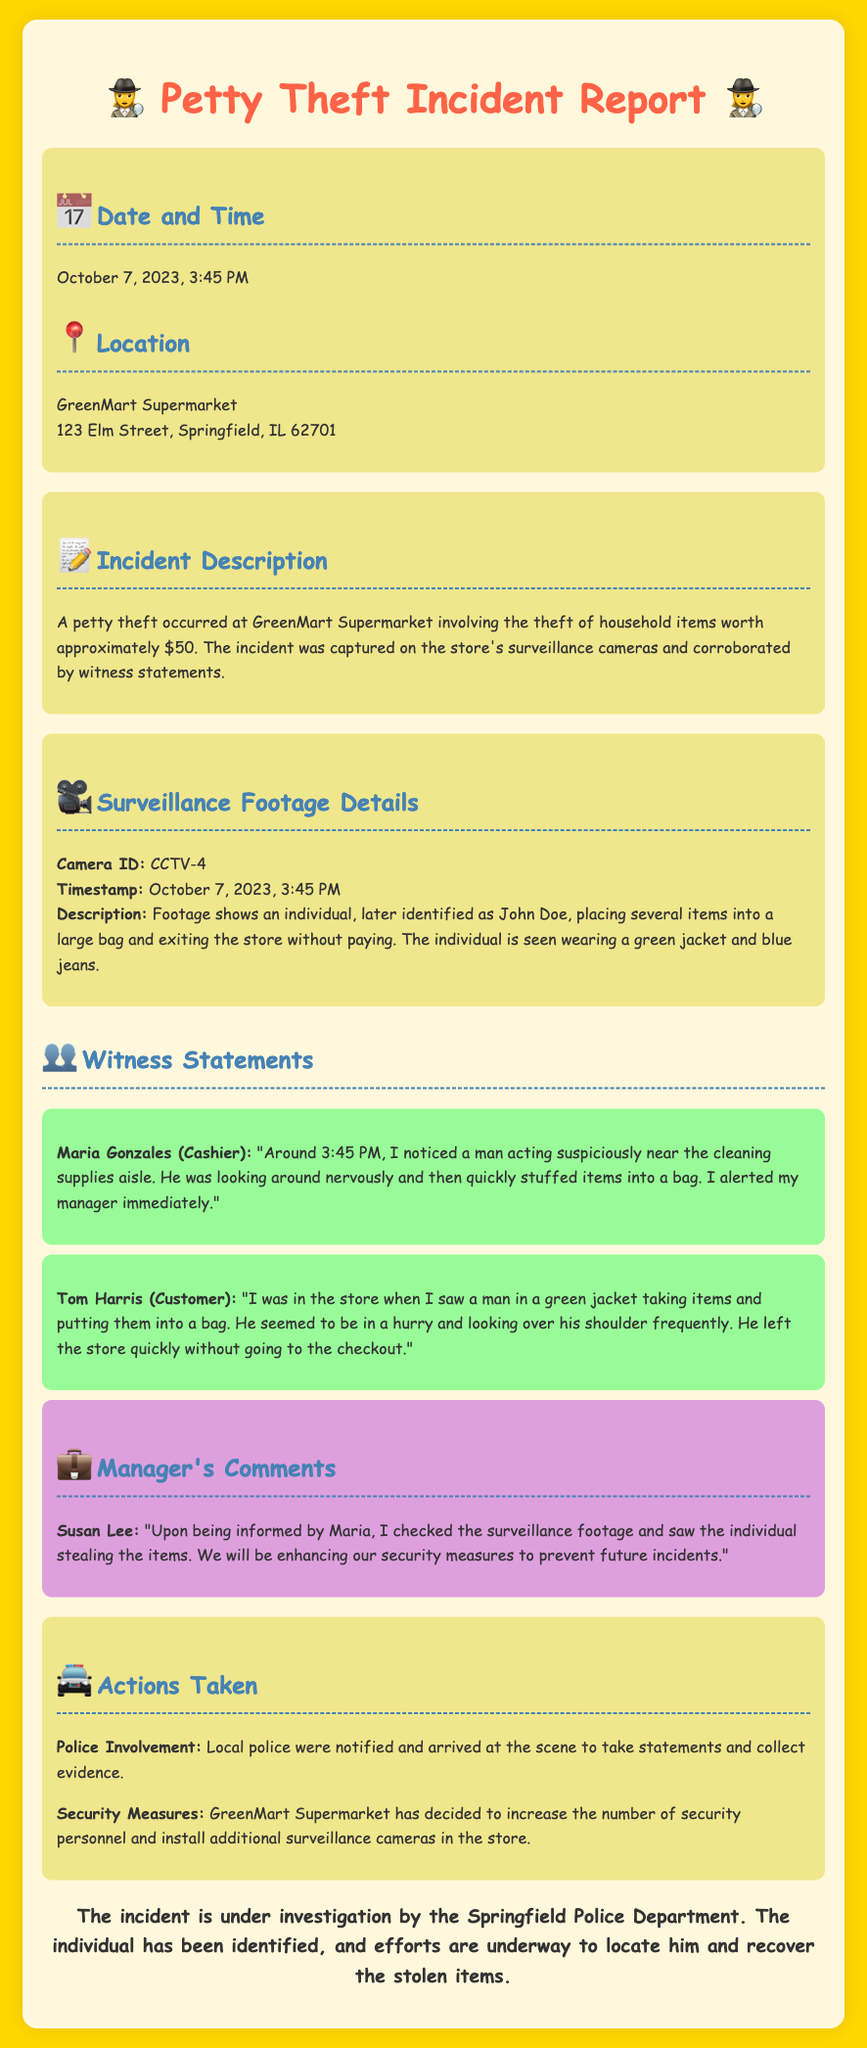What date did the incident occur? The date of the incident is stated in the report as October 7, 2023.
Answer: October 7, 2023 Who was the witness making the first statement? The first witness statement in the document is provided by Maria Gonzales, the cashier.
Answer: Maria Gonzales What items were stolen? The incident report mentions that household items worth approximately $50 were stolen.
Answer: Household items worth approximately $50 What was the suspect wearing? According to the surveillance footage details, the individual is described as wearing a green jacket and blue jeans.
Answer: Green jacket and blue jeans What was the manager's name? The manager who commented on the incident is identified in the report as Susan Lee.
Answer: Susan Lee What actions were taken by the local police? The document states that the local police were notified and arrived at the scene to take statements and collect evidence.
Answer: Notified and collected evidence How did Tom Harris describe the suspect's behavior? Tom Harris described the suspect as acting hurriedly and looking over his shoulder frequently.
Answer: In a hurry and looking over his shoulder What security measures will GreenMart implement? GreenMart plans to increase the number of security personnel and install additional surveillance cameras.
Answer: Increase security personnel and install cameras What camera was used to capture the footage? The report mentions that the camera used to capture the footage is identified as CCTV-4.
Answer: CCTV-4 